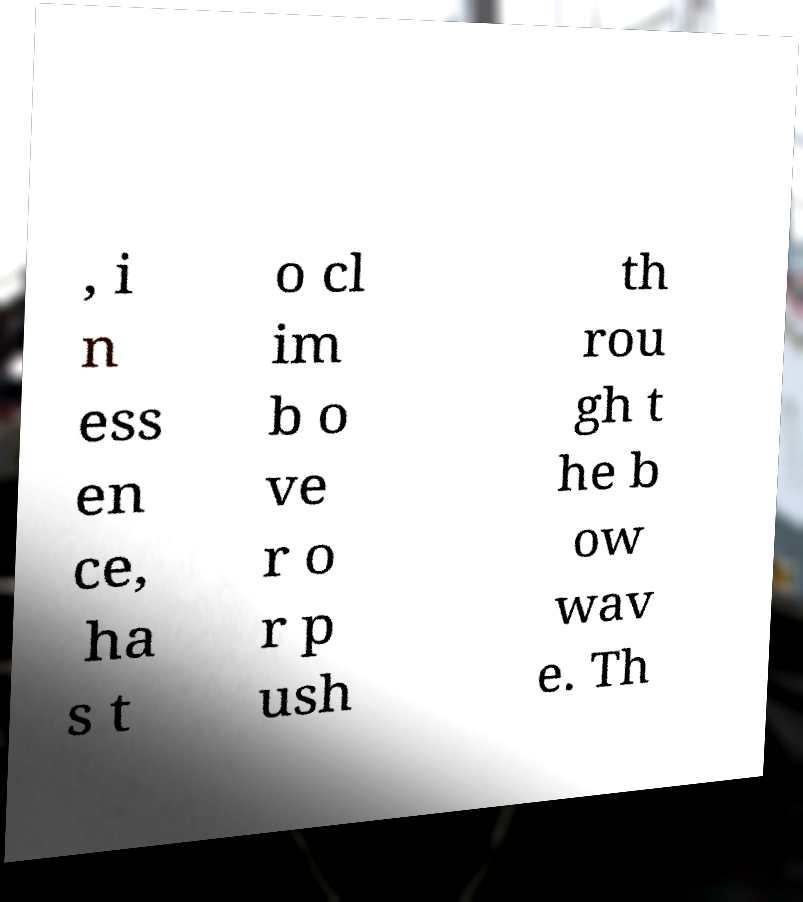For documentation purposes, I need the text within this image transcribed. Could you provide that? , i n ess en ce, ha s t o cl im b o ve r o r p ush th rou gh t he b ow wav e. Th 